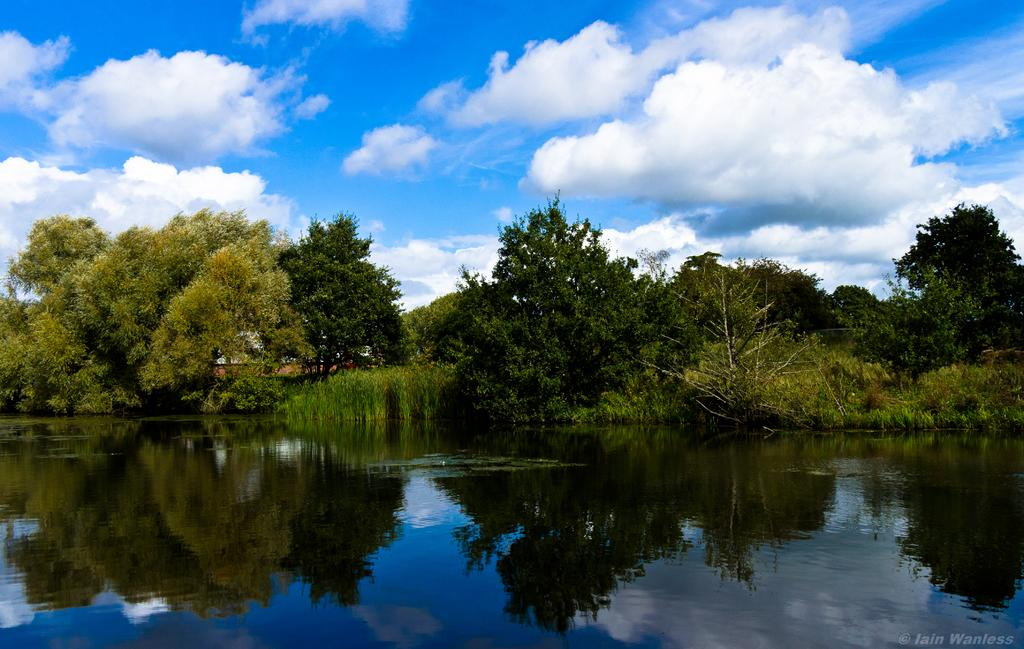What type of vegetation can be seen in the image? There is a group of trees in the image. What natural element is visible besides the trees? There is water visible in the image. What is the condition of the sky in the background of the image? The sky is cloudy in the background of the image. Where is the desk located in the image? There is no desk present in the image. What type of stick can be seen in the water in the image? There is no stick visible in the water in the image. 